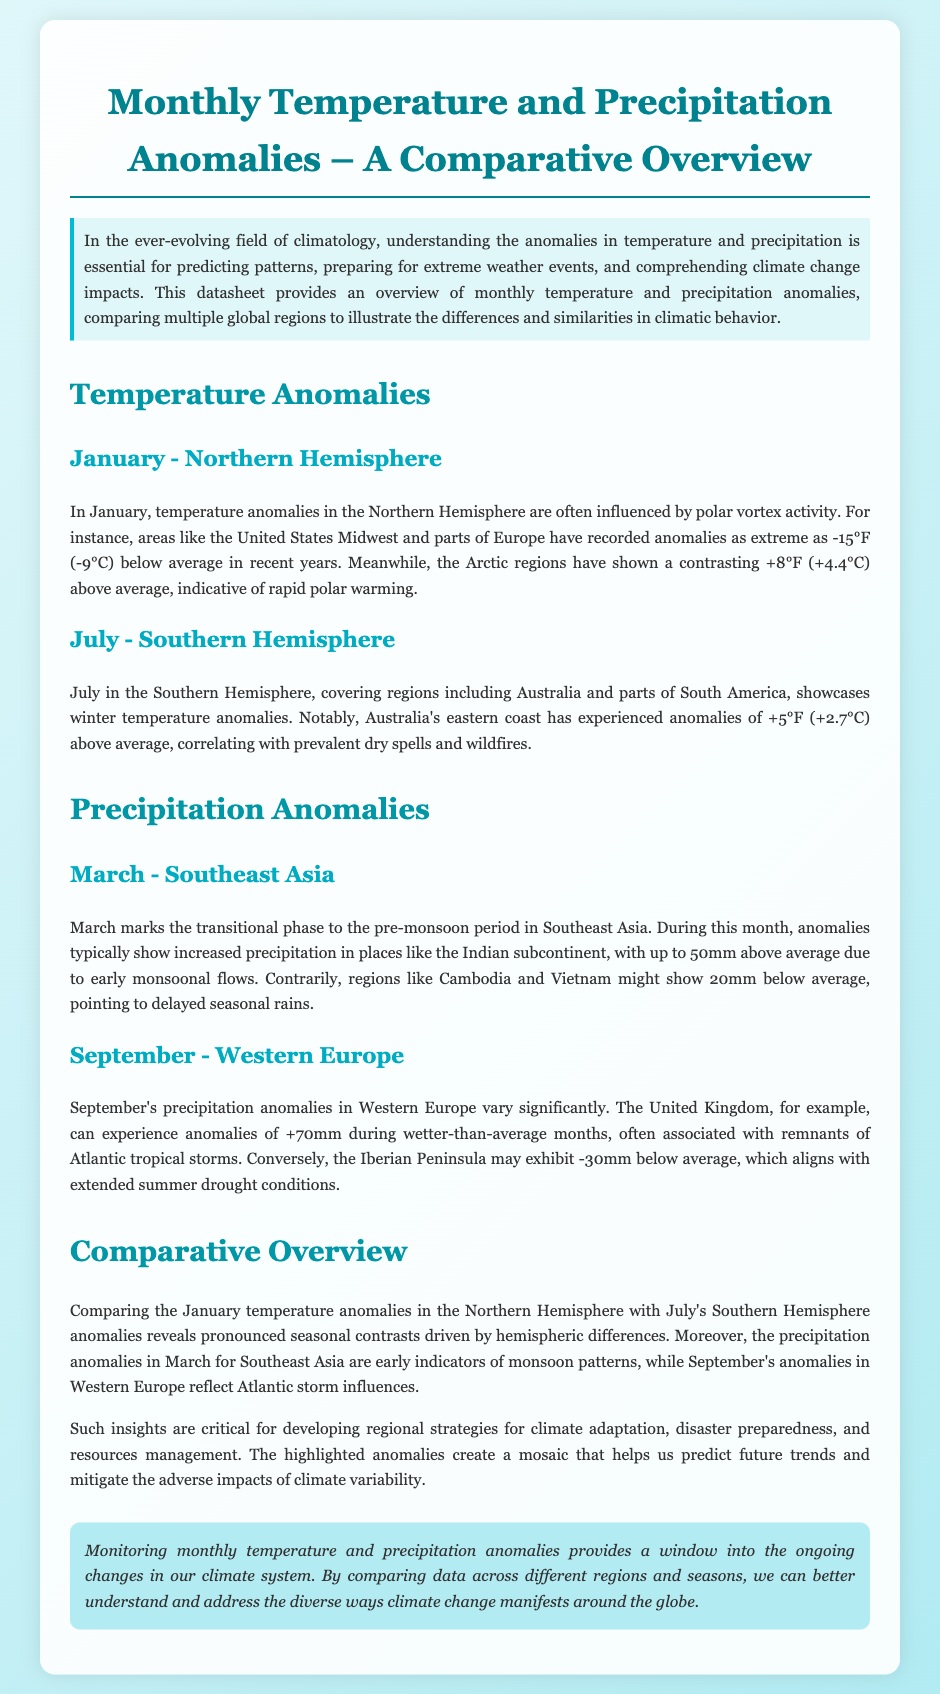What temperature anomaly was recorded in the Arctic in January? The Arctic regions have shown a contrasting +8°F (+4.4°C) above average.
Answer: +8°F (+4.4°C) What is the typical precipitation anomaly in Southeast Asia during March? During this month, anomalies typically show increased precipitation in places like the Indian subcontinent, with up to 50mm above average.
Answer: up to 50mm Which region experienced +5°F anomalies in July? Australia's eastern coast has experienced anomalies of +5°F above average.
Answer: Australia's eastern coast What are the precipitation anomalies in the United Kingdom during September? The United Kingdom can experience anomalies of +70mm during wetter-than-average months.
Answer: +70mm What seasonal contrasts are highlighted between January and July? The comparison reveals pronounced seasonal contrasts driven by hemispheric differences.
Answer: pronounced seasonal contrasts What does the datasheet provide insights for? The highlighted anomalies create a mosaic that helps us predict future trends and mitigate the adverse impacts of climate variability.
Answer: future trends and mitigate impacts What month marks the transitional phase to the pre-monsoon period in Southeast Asia? March marks the transitional phase to the pre-monsoon period in Southeast Asia.
Answer: March What type of anomalies are present in the Iberian Peninsula during September? The Iberian Peninsula may exhibit -30mm below average, which aligns with extended summer drought conditions.
Answer: -30mm below average What does monitoring temperature and precipitation anomalies help us understand? Monitoring monthly temperature and precipitation anomalies provides a window into the ongoing changes in our climate system.
Answer: ongoing changes in our climate system 